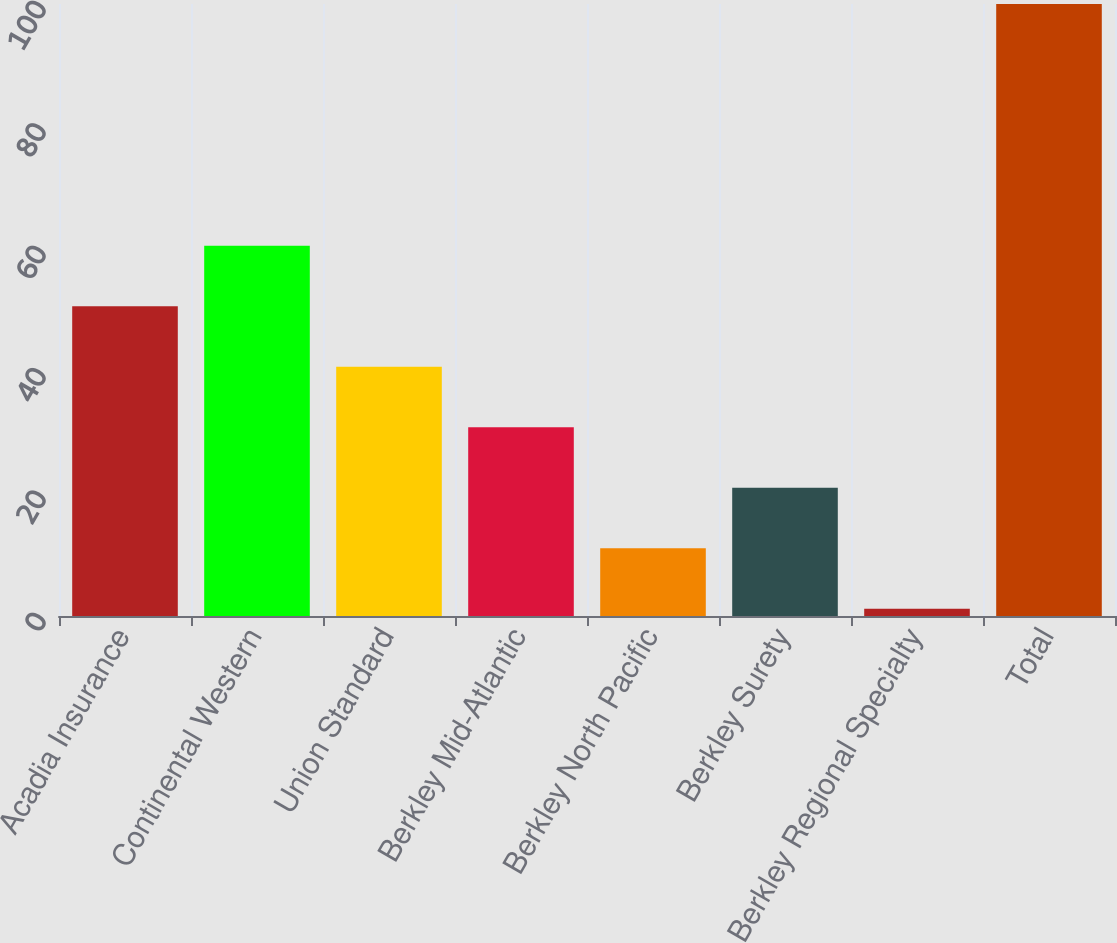<chart> <loc_0><loc_0><loc_500><loc_500><bar_chart><fcel>Acadia Insurance<fcel>Continental Western<fcel>Union Standard<fcel>Berkley Mid-Atlantic<fcel>Berkley North Pacific<fcel>Berkley Surety<fcel>Berkley Regional Specialty<fcel>Total<nl><fcel>50.6<fcel>60.48<fcel>40.72<fcel>30.84<fcel>11.08<fcel>20.96<fcel>1.2<fcel>100<nl></chart> 